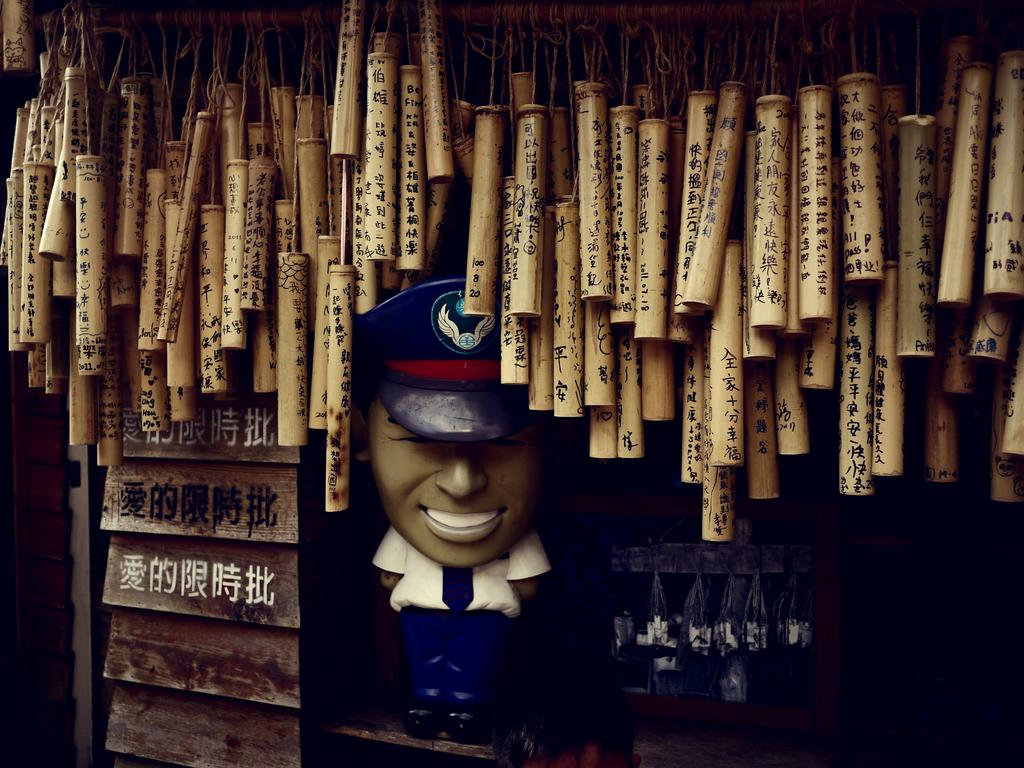<image>
Provide a brief description of the given image. A group of bamboo tubes in asian caligraphy with the one closest to a statue of a postman having the numbers 100, 8 and 20. 